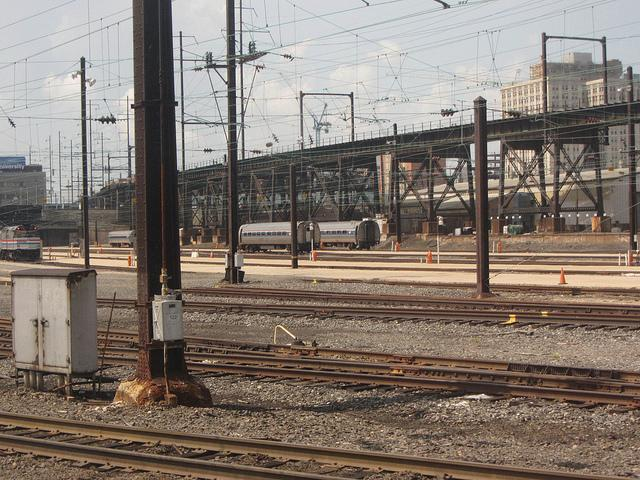What mode of transport is in the picture above?

Choices:
A) road
B) water
C) air
D) railway railway 